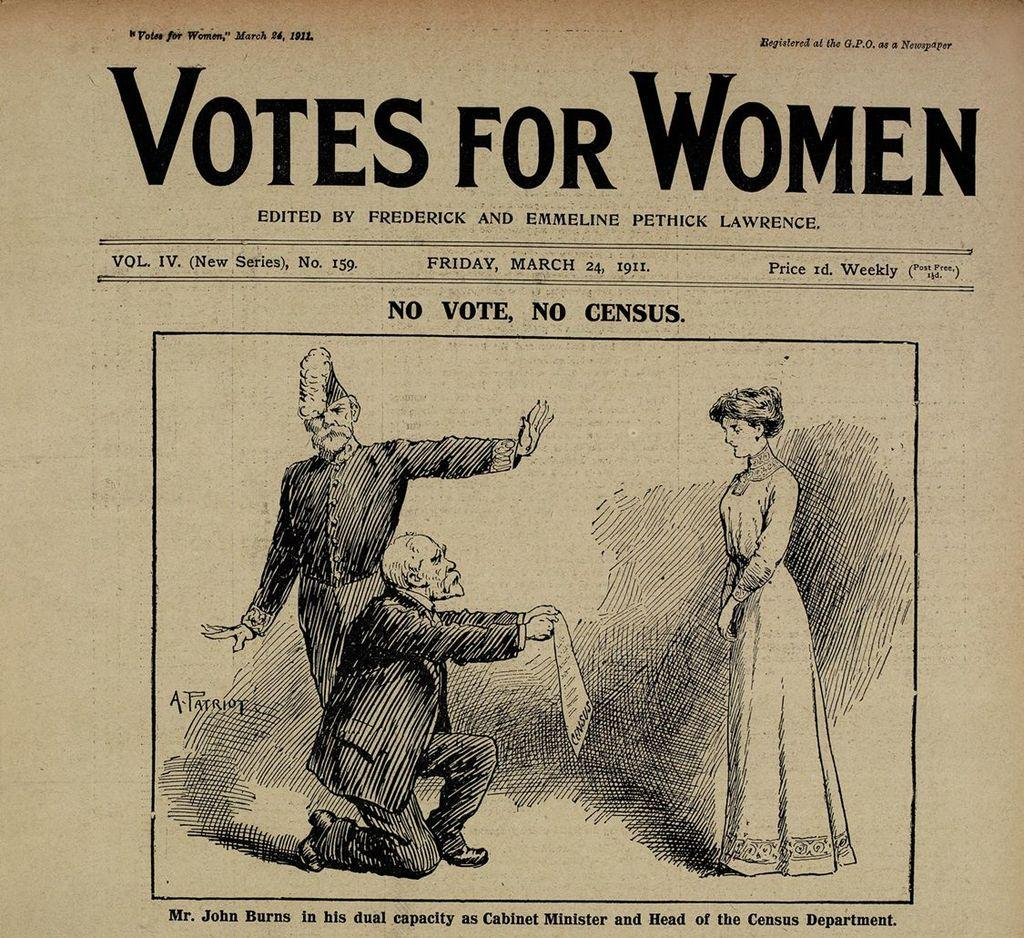What type of visual might the image be? The image might be a poster. What can be seen in the center of the image? There is a drawing of two men and one woman in the center of the image. Where is text located in the image? There is text at the top and bottom of the image. What type of rhythm can be heard in the background of the image? There is no audible rhythm present in the image, as it is a visual medium. 